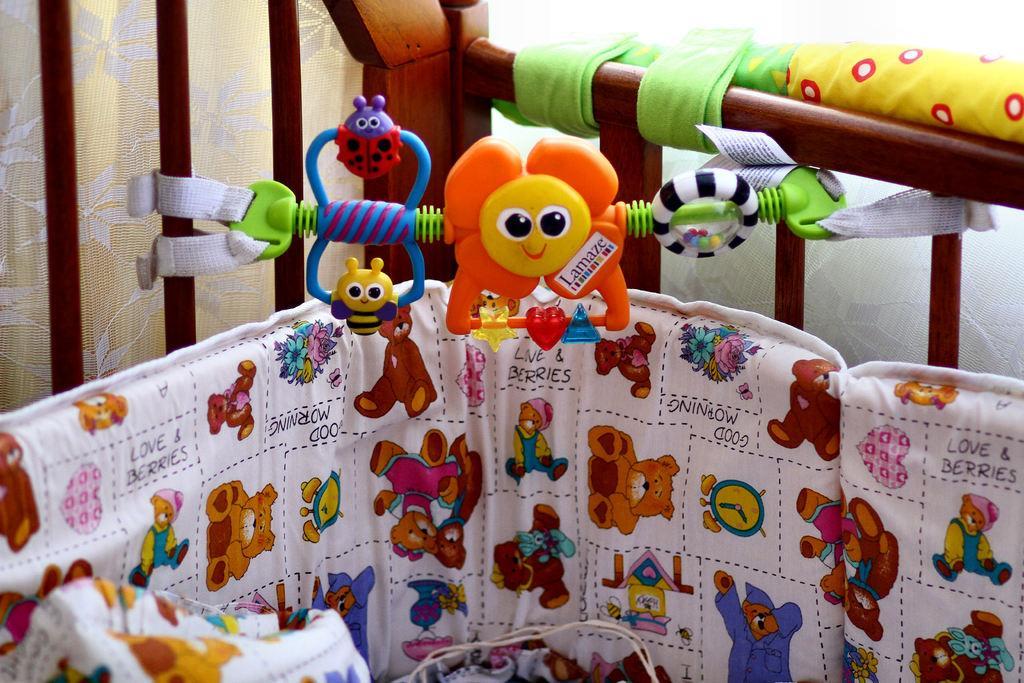Describe this image in one or two sentences. In this image there is a cradle with toys. In the background of the image there are curtains. 